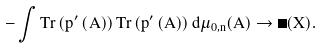Convert formula to latex. <formula><loc_0><loc_0><loc_500><loc_500>- \int T r \left ( p ^ { \prime } \left ( A \right ) \right ) T r \left ( p ^ { \prime } \left ( A \right ) \right ) d \mu _ { 0 , n } ( A ) \rightarrow \Phi ( X ) .</formula> 